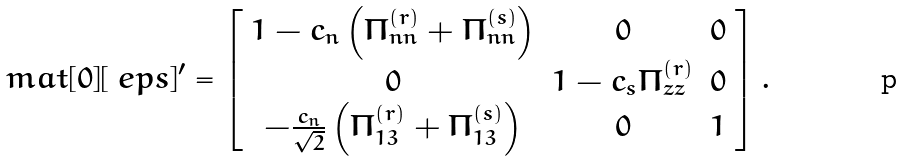<formula> <loc_0><loc_0><loc_500><loc_500>\ m a t [ 0 ] [ \ e p s ] ^ { \prime } = \left [ \begin{array} { c c c } 1 - c _ { n } \left ( \Pi _ { n n } ^ { ( r ) } + \Pi _ { n n } ^ { ( s ) } \right ) & 0 & 0 \\ 0 & 1 - c _ { s } \Pi _ { z z } ^ { ( r ) } & 0 \\ - \frac { c _ { n } } { \sqrt { 2 } } \left ( \Pi _ { 1 3 } ^ { ( r ) } + \Pi _ { 1 3 } ^ { ( s ) } \right ) & 0 & 1 \end{array} \right ] .</formula> 